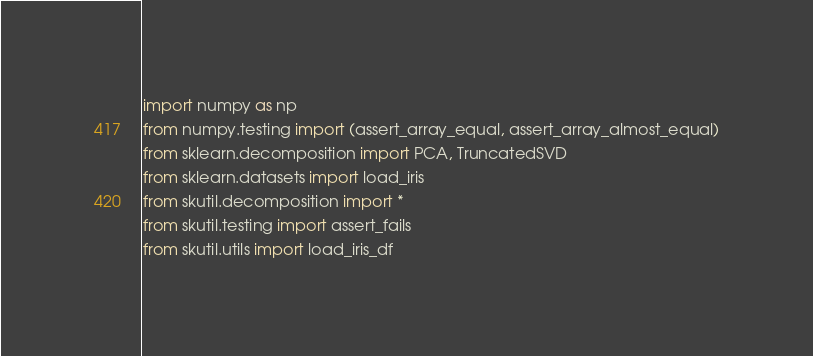<code> <loc_0><loc_0><loc_500><loc_500><_Python_>import numpy as np
from numpy.testing import (assert_array_equal, assert_array_almost_equal)
from sklearn.decomposition import PCA, TruncatedSVD
from sklearn.datasets import load_iris
from skutil.decomposition import *
from skutil.testing import assert_fails
from skutil.utils import load_iris_df</code> 